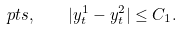Convert formula to latex. <formula><loc_0><loc_0><loc_500><loc_500>\ p t s , \quad | y ^ { 1 } _ { t } - y ^ { 2 } _ { t } | \leq C _ { 1 } .</formula> 